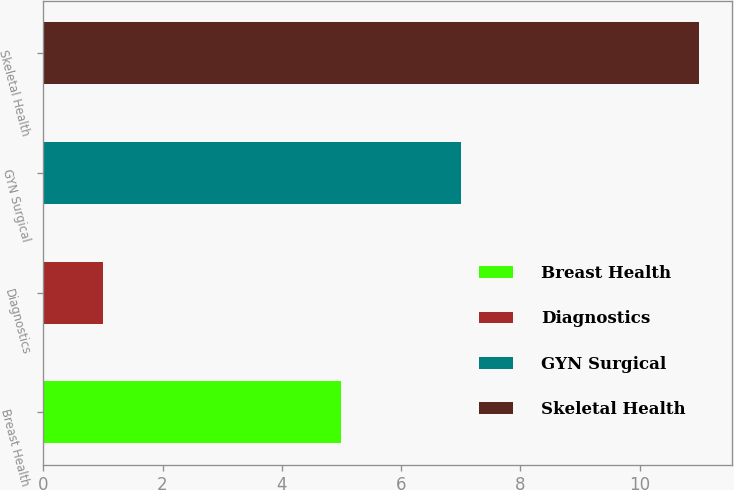Convert chart to OTSL. <chart><loc_0><loc_0><loc_500><loc_500><bar_chart><fcel>Breast Health<fcel>Diagnostics<fcel>GYN Surgical<fcel>Skeletal Health<nl><fcel>5<fcel>1<fcel>7<fcel>11<nl></chart> 